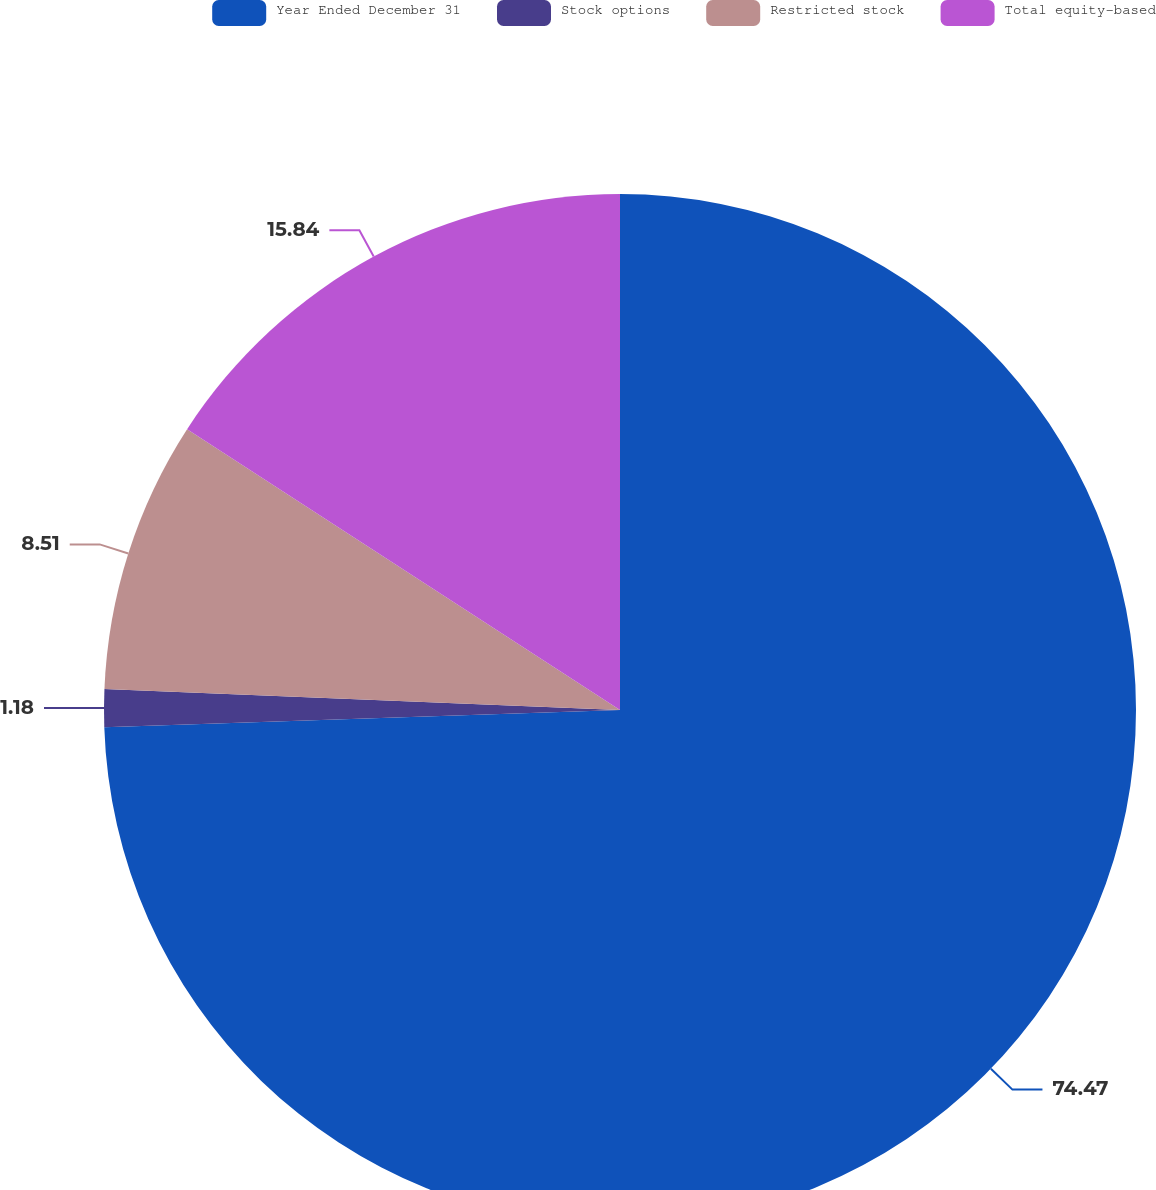<chart> <loc_0><loc_0><loc_500><loc_500><pie_chart><fcel>Year Ended December 31<fcel>Stock options<fcel>Restricted stock<fcel>Total equity-based<nl><fcel>74.47%<fcel>1.18%<fcel>8.51%<fcel>15.84%<nl></chart> 